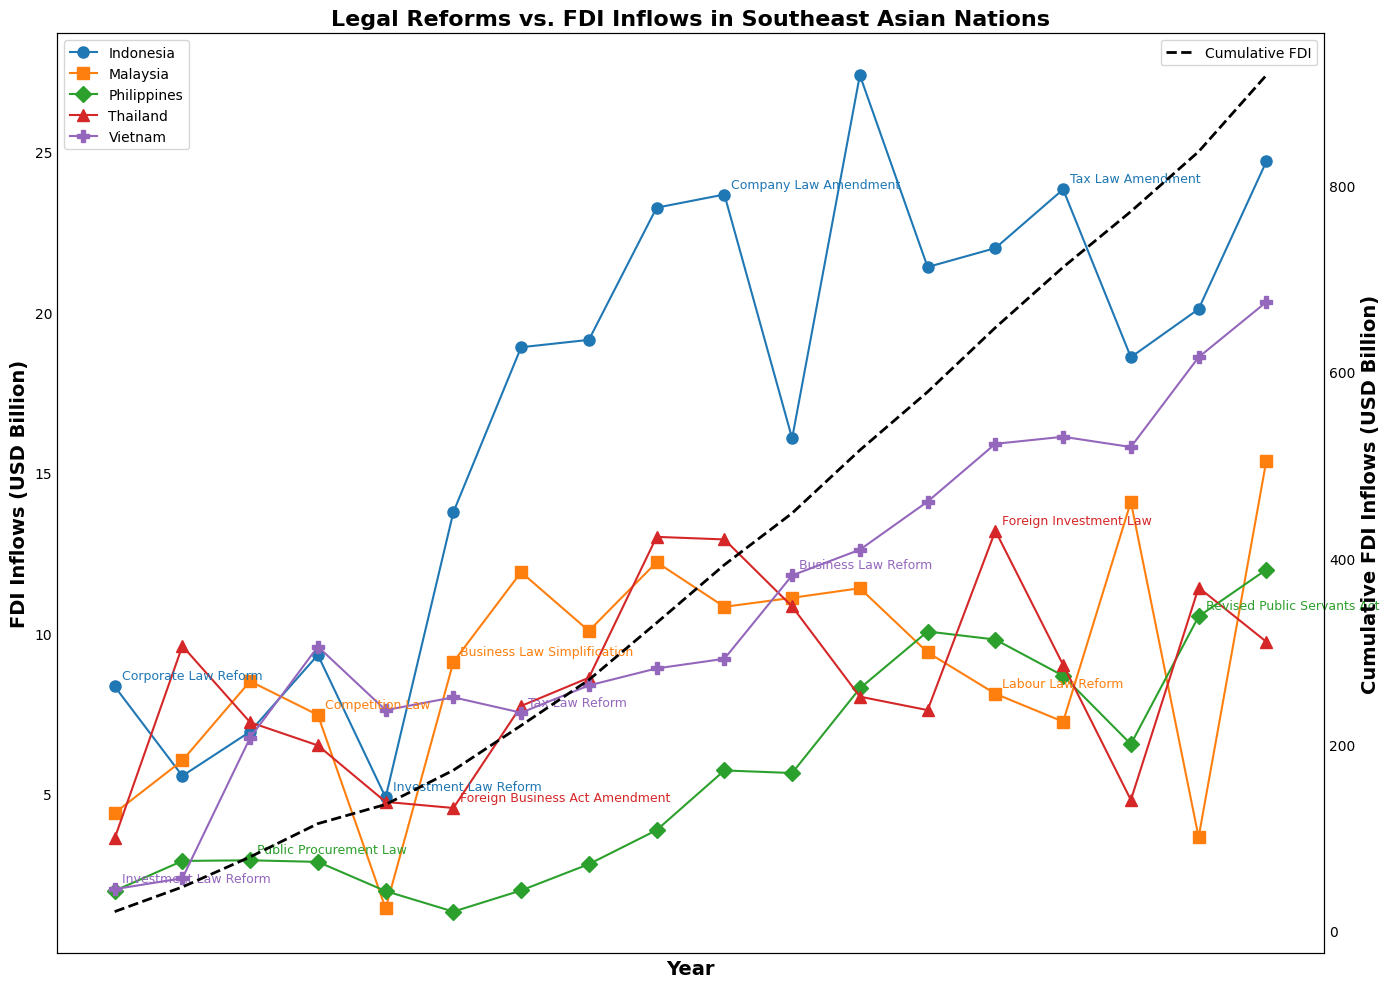What's the trend of FDI inflows in Indonesia from 2005 to 2022? To answer this, observe the line representing Indonesia on the figure. Indonesia's FDI inflows show an overall increasing trend, with notable rises in 2013 and 2016, peaking around 2016 (27.39 billion USD) before slightly decreasing and then rising again towards 2022 (24.70 billion USD).
Answer: Increasing trend with peaks Which country experienced the highest FDI inflows in 2013, and what was the amount? Locate the data points for each country in 2013 and identify the highest one. The highest FDI inflow in 2013 was in Indonesia with an amount of 23.26 billion USD.
Answer: Indonesia, 23.26 billion USD How did the cumulative FDI inflows change over time according to the dashed line? Follow the dashed line representing cumulative FDI inflows from the leftmost to the rightmost side of the plot. The cumulative FDI inflows exhibit a consistent upward trend, indicating a continual increase in total FDI over time.
Answer: Increasing trend Did any countries show a significant increase in FDI inflows following a legal reform? Give an example. Observe the years where legal reforms took place and check the subsequent FDI inflows. For example, Vietnam's FDI inflows significantly increased after the Business Law Reform in 2015, from 11.80 billion in 2015 to 12.60 billion in 2016.
Answer: Yes, Vietnam in 2015/2016 Compare the FDI inflows of Vietnam and the Philippines in 2022. Which country had higher inflows and by how much? Locate the data points for Vietnam and the Philippines in 2022, and calculate the difference. Vietnam's FDI inflows were 20.32 billion USD, while the Philippines' were 11.98 billion USD. The difference is 20.32 - 11.98 = 8.34 billion USD, with Vietnam having higher inflows.
Answer: Vietnam, 8.34 billion USD What was the impact of Malaysia's Labour Law Reform in 2018 on its FDI inflows? Locate the FDI values for Malaysia before and after 2018. In 2018, Malaysia had Labour Law Reform, with FDI inflows of 8.11 billion USD compared to the previous year's 9.40 billion USD, indicating a decrease.
Answer: Decrease Which country had the most consistent FDI inflows over the years, and which country had the most variable? Compare the stability of the data points for each country. The Philippines appear to have the most consistent FDI inflows with smaller fluctuations, whereas Indonesia had more noticeable variability with higher peaks and troughs.
Answer: Most consistent: Philippines, Most variable: Indonesia 